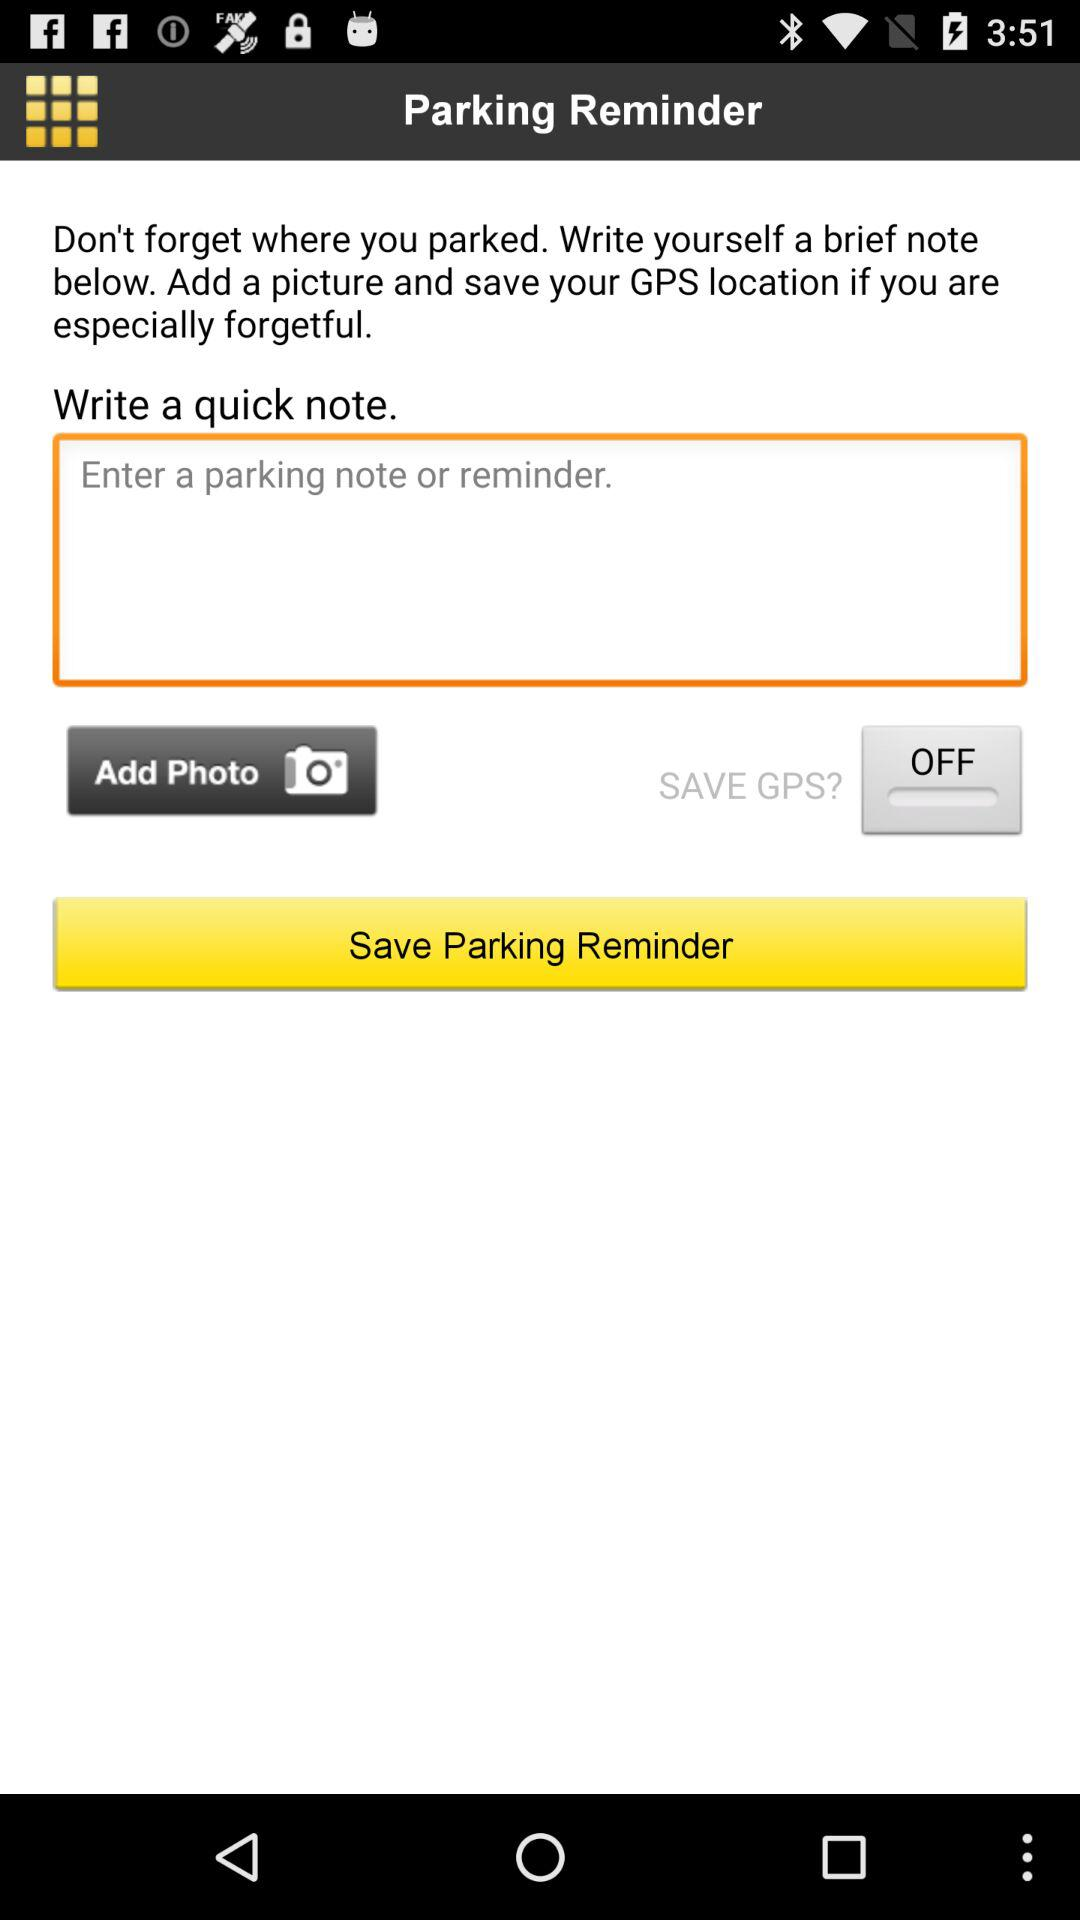What is the application name? The name of the application is "Parking Reminder". 